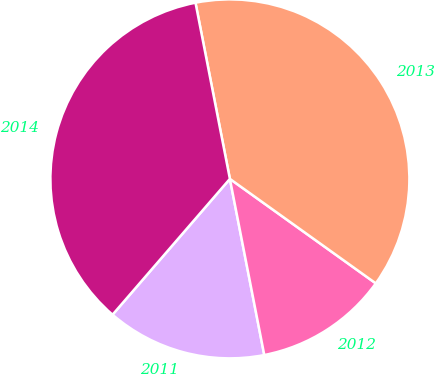Convert chart to OTSL. <chart><loc_0><loc_0><loc_500><loc_500><pie_chart><fcel>2011<fcel>2012<fcel>2013<fcel>2014<nl><fcel>14.41%<fcel>12.04%<fcel>37.96%<fcel>35.59%<nl></chart> 